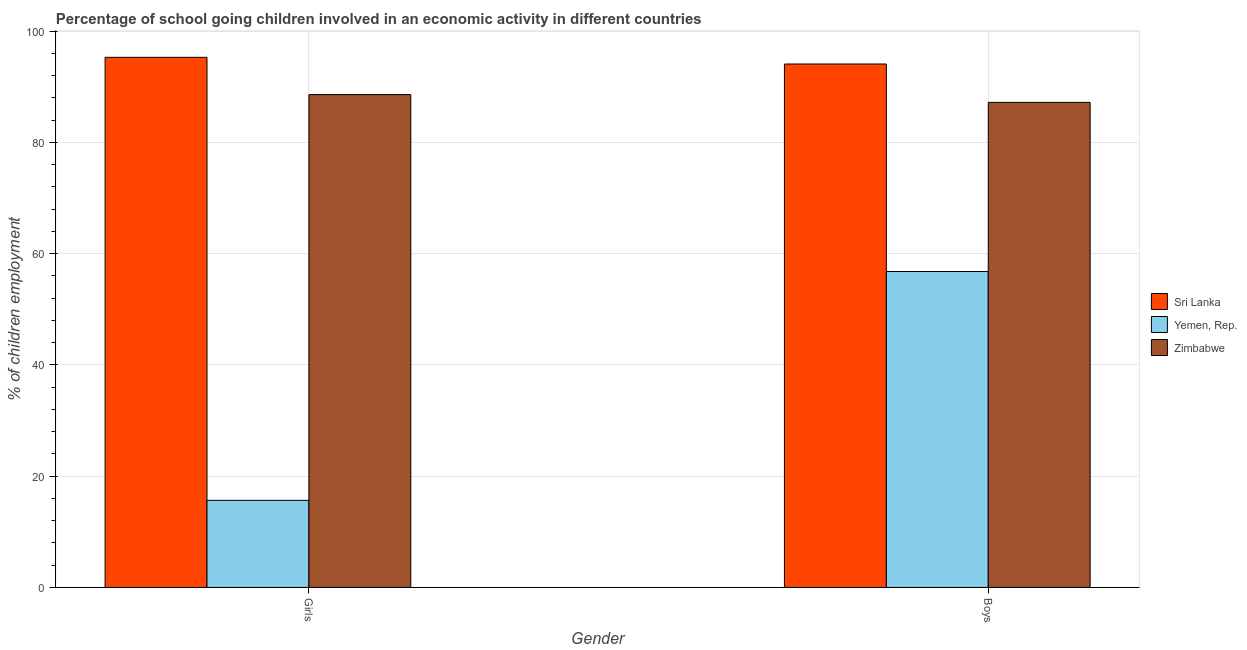How many different coloured bars are there?
Provide a short and direct response. 3. How many groups of bars are there?
Ensure brevity in your answer.  2. Are the number of bars per tick equal to the number of legend labels?
Provide a succinct answer. Yes. Are the number of bars on each tick of the X-axis equal?
Ensure brevity in your answer.  Yes. How many bars are there on the 2nd tick from the right?
Your answer should be very brief. 3. What is the label of the 1st group of bars from the left?
Keep it short and to the point. Girls. What is the percentage of school going girls in Sri Lanka?
Make the answer very short. 95.3. Across all countries, what is the maximum percentage of school going girls?
Your answer should be compact. 95.3. Across all countries, what is the minimum percentage of school going boys?
Your response must be concise. 56.8. In which country was the percentage of school going boys maximum?
Provide a succinct answer. Sri Lanka. In which country was the percentage of school going boys minimum?
Your response must be concise. Yemen, Rep. What is the total percentage of school going girls in the graph?
Make the answer very short. 199.56. What is the difference between the percentage of school going boys in Zimbabwe and that in Sri Lanka?
Give a very brief answer. -6.9. What is the difference between the percentage of school going boys in Zimbabwe and the percentage of school going girls in Yemen, Rep.?
Offer a terse response. 71.54. What is the average percentage of school going girls per country?
Your answer should be compact. 66.52. What is the difference between the percentage of school going boys and percentage of school going girls in Sri Lanka?
Provide a short and direct response. -1.2. What is the ratio of the percentage of school going girls in Zimbabwe to that in Sri Lanka?
Provide a succinct answer. 0.93. What does the 1st bar from the left in Girls represents?
Your answer should be very brief. Sri Lanka. What does the 1st bar from the right in Girls represents?
Your answer should be very brief. Zimbabwe. How many bars are there?
Provide a short and direct response. 6. How many countries are there in the graph?
Your answer should be compact. 3. What is the difference between two consecutive major ticks on the Y-axis?
Provide a succinct answer. 20. Are the values on the major ticks of Y-axis written in scientific E-notation?
Make the answer very short. No. Does the graph contain any zero values?
Provide a short and direct response. No. Does the graph contain grids?
Your response must be concise. Yes. What is the title of the graph?
Make the answer very short. Percentage of school going children involved in an economic activity in different countries. Does "Nigeria" appear as one of the legend labels in the graph?
Your answer should be compact. No. What is the label or title of the X-axis?
Offer a terse response. Gender. What is the label or title of the Y-axis?
Your answer should be compact. % of children employment. What is the % of children employment of Sri Lanka in Girls?
Make the answer very short. 95.3. What is the % of children employment in Yemen, Rep. in Girls?
Ensure brevity in your answer.  15.66. What is the % of children employment in Zimbabwe in Girls?
Your response must be concise. 88.6. What is the % of children employment of Sri Lanka in Boys?
Make the answer very short. 94.1. What is the % of children employment of Yemen, Rep. in Boys?
Offer a very short reply. 56.8. What is the % of children employment of Zimbabwe in Boys?
Keep it short and to the point. 87.2. Across all Gender, what is the maximum % of children employment of Sri Lanka?
Ensure brevity in your answer.  95.3. Across all Gender, what is the maximum % of children employment in Yemen, Rep.?
Ensure brevity in your answer.  56.8. Across all Gender, what is the maximum % of children employment of Zimbabwe?
Offer a terse response. 88.6. Across all Gender, what is the minimum % of children employment in Sri Lanka?
Your answer should be compact. 94.1. Across all Gender, what is the minimum % of children employment in Yemen, Rep.?
Your answer should be very brief. 15.66. Across all Gender, what is the minimum % of children employment of Zimbabwe?
Your answer should be compact. 87.2. What is the total % of children employment in Sri Lanka in the graph?
Give a very brief answer. 189.4. What is the total % of children employment of Yemen, Rep. in the graph?
Provide a succinct answer. 72.45. What is the total % of children employment in Zimbabwe in the graph?
Your answer should be compact. 175.8. What is the difference between the % of children employment in Yemen, Rep. in Girls and that in Boys?
Ensure brevity in your answer.  -41.14. What is the difference between the % of children employment in Zimbabwe in Girls and that in Boys?
Your response must be concise. 1.4. What is the difference between the % of children employment in Sri Lanka in Girls and the % of children employment in Yemen, Rep. in Boys?
Your answer should be very brief. 38.5. What is the difference between the % of children employment of Yemen, Rep. in Girls and the % of children employment of Zimbabwe in Boys?
Your answer should be very brief. -71.55. What is the average % of children employment in Sri Lanka per Gender?
Offer a terse response. 94.7. What is the average % of children employment in Yemen, Rep. per Gender?
Provide a short and direct response. 36.23. What is the average % of children employment of Zimbabwe per Gender?
Offer a very short reply. 87.9. What is the difference between the % of children employment in Sri Lanka and % of children employment in Yemen, Rep. in Girls?
Provide a succinct answer. 79.64. What is the difference between the % of children employment of Yemen, Rep. and % of children employment of Zimbabwe in Girls?
Keep it short and to the point. -72.94. What is the difference between the % of children employment of Sri Lanka and % of children employment of Yemen, Rep. in Boys?
Make the answer very short. 37.3. What is the difference between the % of children employment in Yemen, Rep. and % of children employment in Zimbabwe in Boys?
Give a very brief answer. -30.4. What is the ratio of the % of children employment of Sri Lanka in Girls to that in Boys?
Provide a short and direct response. 1.01. What is the ratio of the % of children employment in Yemen, Rep. in Girls to that in Boys?
Ensure brevity in your answer.  0.28. What is the ratio of the % of children employment of Zimbabwe in Girls to that in Boys?
Your answer should be very brief. 1.02. What is the difference between the highest and the second highest % of children employment in Yemen, Rep.?
Provide a short and direct response. 41.14. What is the difference between the highest and the second highest % of children employment of Zimbabwe?
Keep it short and to the point. 1.4. What is the difference between the highest and the lowest % of children employment in Sri Lanka?
Keep it short and to the point. 1.2. What is the difference between the highest and the lowest % of children employment of Yemen, Rep.?
Provide a short and direct response. 41.14. What is the difference between the highest and the lowest % of children employment in Zimbabwe?
Ensure brevity in your answer.  1.4. 